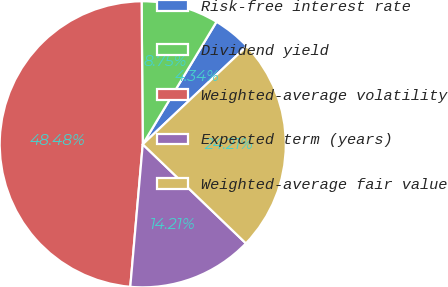Convert chart to OTSL. <chart><loc_0><loc_0><loc_500><loc_500><pie_chart><fcel>Risk-free interest rate<fcel>Dividend yield<fcel>Weighted-average volatility<fcel>Expected term (years)<fcel>Weighted-average fair value<nl><fcel>4.34%<fcel>8.75%<fcel>48.48%<fcel>14.21%<fcel>24.21%<nl></chart> 